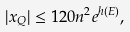<formula> <loc_0><loc_0><loc_500><loc_500>| x _ { Q } | \leq 1 2 0 n ^ { 2 } e ^ { h ( E ) } ,</formula> 